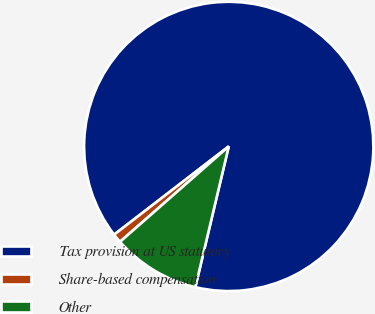Convert chart to OTSL. <chart><loc_0><loc_0><loc_500><loc_500><pie_chart><fcel>Tax provision at US statutory<fcel>Share-based compensation<fcel>Other<nl><fcel>89.15%<fcel>1.02%<fcel>9.83%<nl></chart> 